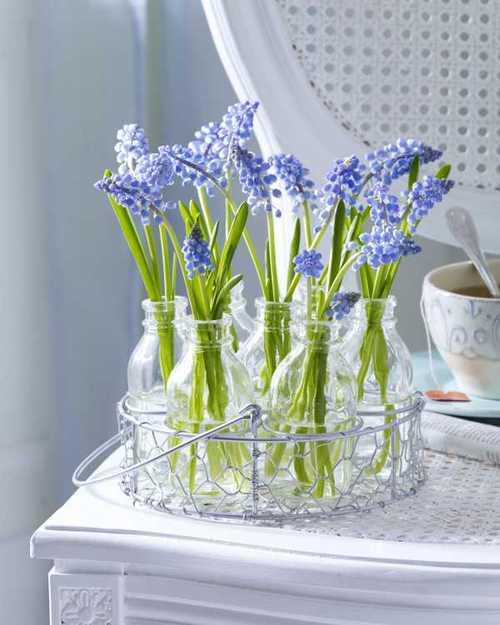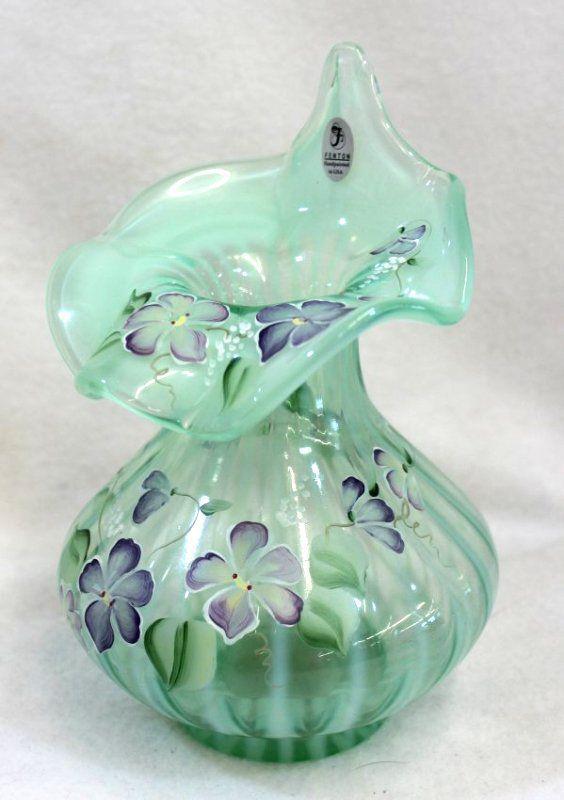The first image is the image on the left, the second image is the image on the right. Given the left and right images, does the statement "At least one photo features cactus-shaped vases." hold true? Answer yes or no. No. The first image is the image on the left, the second image is the image on the right. For the images shown, is this caption "At least one image features vases that look like cacti." true? Answer yes or no. No. 